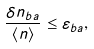<formula> <loc_0><loc_0><loc_500><loc_500>\frac { \delta n _ { b a } } { \langle n \rangle } \leq \varepsilon _ { b a } ,</formula> 